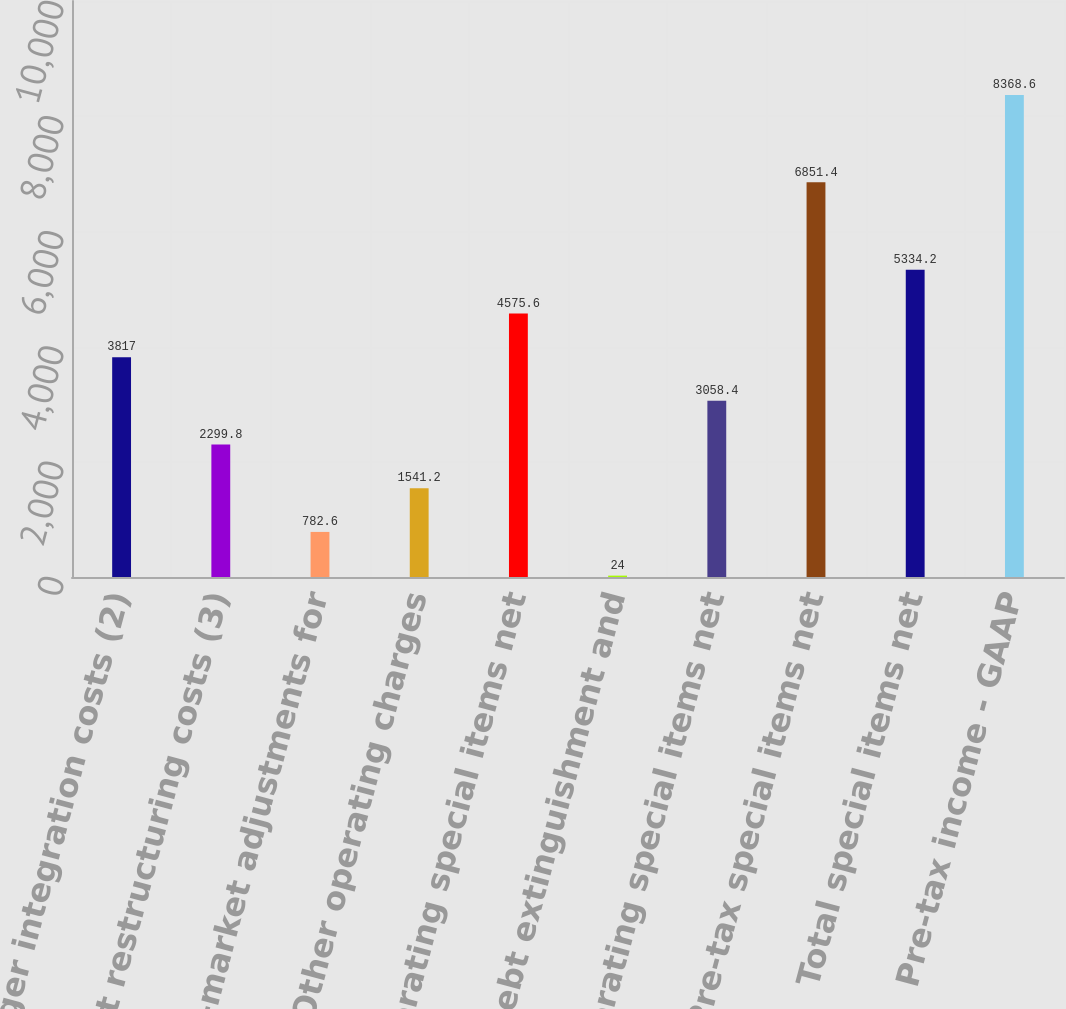Convert chart to OTSL. <chart><loc_0><loc_0><loc_500><loc_500><bar_chart><fcel>Merger integration costs (2)<fcel>Fleet restructuring costs (3)<fcel>Mark-to-market adjustments for<fcel>Other operating charges<fcel>Operating special items net<fcel>Debt extinguishment and<fcel>Nonoperating special items net<fcel>Pre-tax special items net<fcel>Total special items net<fcel>Pre-tax income - GAAP<nl><fcel>3817<fcel>2299.8<fcel>782.6<fcel>1541.2<fcel>4575.6<fcel>24<fcel>3058.4<fcel>6851.4<fcel>5334.2<fcel>8368.6<nl></chart> 